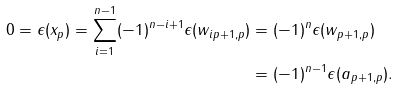Convert formula to latex. <formula><loc_0><loc_0><loc_500><loc_500>0 = \epsilon ( x _ { p } ) = \sum _ { i = 1 } ^ { n - 1 } ( - 1 ) ^ { n - i + 1 } \epsilon ( w _ { i p + 1 , p } ) & = ( - 1 ) ^ { n } \epsilon ( w _ { p + 1 , p } ) \\ & = ( - 1 ) ^ { n - 1 } \epsilon ( a _ { p + 1 , p } ) .</formula> 